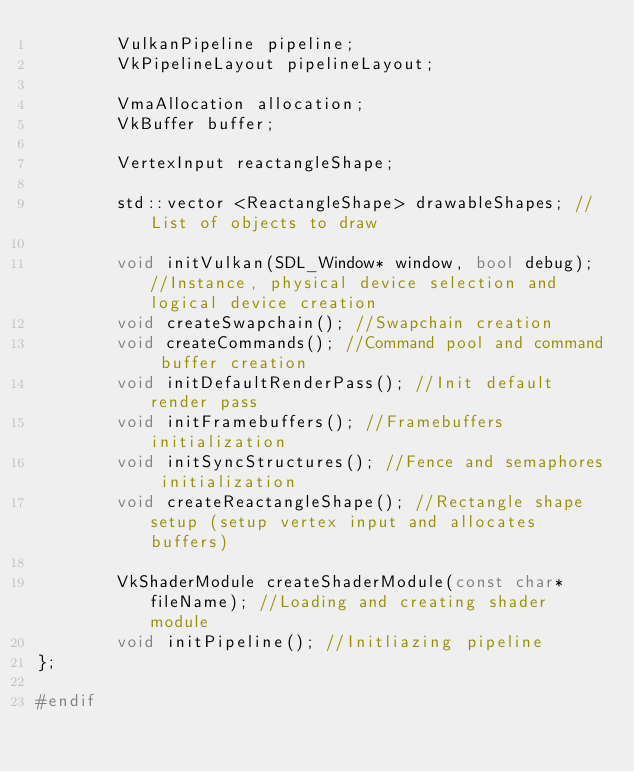<code> <loc_0><loc_0><loc_500><loc_500><_C++_>        VulkanPipeline pipeline;
        VkPipelineLayout pipelineLayout;

        VmaAllocation allocation;
        VkBuffer buffer;

        VertexInput reactangleShape;

        std::vector <ReactangleShape> drawableShapes; //List of objects to draw

        void initVulkan(SDL_Window* window, bool debug); //Instance, physical device selection and logical device creation
        void createSwapchain(); //Swapchain creation
        void createCommands(); //Command pool and command buffer creation
        void initDefaultRenderPass(); //Init default render pass
        void initFramebuffers(); //Framebuffers initialization
        void initSyncStructures(); //Fence and semaphores initialization
        void createReactangleShape(); //Rectangle shape setup (setup vertex input and allocates buffers)

        VkShaderModule createShaderModule(const char* fileName); //Loading and creating shader module
        void initPipeline(); //Initliazing pipeline
};

#endif
</code> 